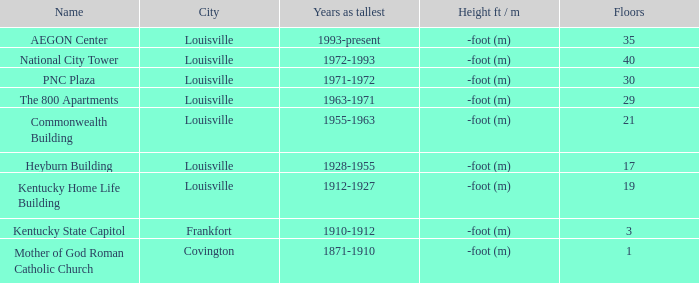In what city does the tallest building have 35 floors? Louisville. 